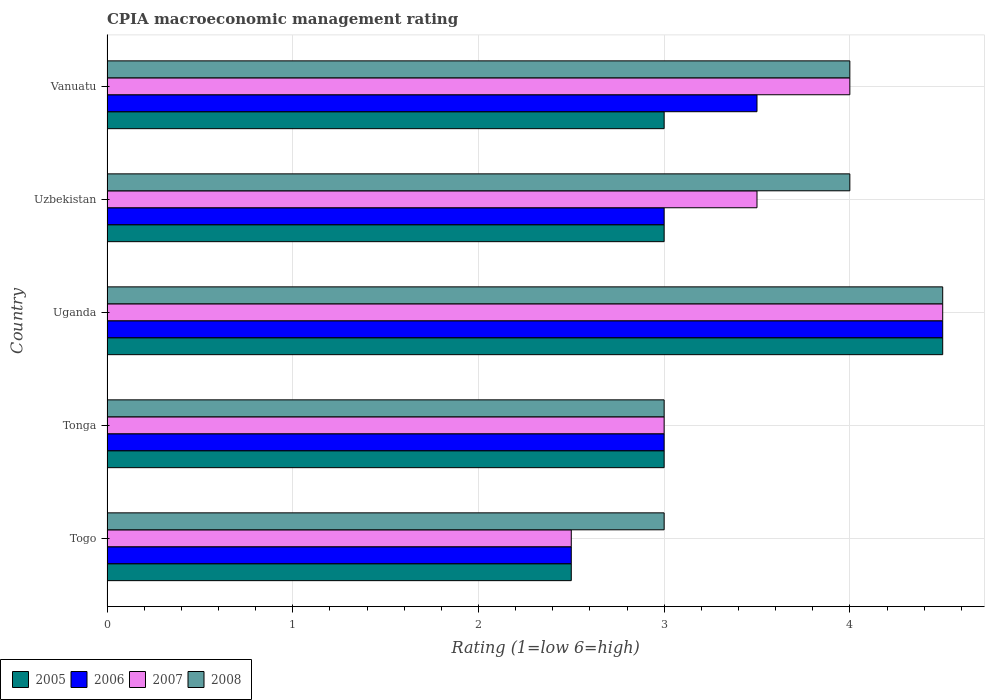How many bars are there on the 1st tick from the top?
Offer a very short reply. 4. What is the label of the 3rd group of bars from the top?
Your answer should be very brief. Uganda. In how many cases, is the number of bars for a given country not equal to the number of legend labels?
Provide a succinct answer. 0. Across all countries, what is the maximum CPIA rating in 2007?
Give a very brief answer. 4.5. In which country was the CPIA rating in 2008 maximum?
Make the answer very short. Uganda. In which country was the CPIA rating in 2006 minimum?
Your answer should be very brief. Togo. What is the difference between the CPIA rating in 2007 in Tonga and the CPIA rating in 2005 in Uganda?
Keep it short and to the point. -1.5. What is the ratio of the CPIA rating in 2005 in Tonga to that in Uganda?
Your answer should be very brief. 0.67. Is the difference between the CPIA rating in 2007 in Tonga and Uzbekistan greater than the difference between the CPIA rating in 2008 in Tonga and Uzbekistan?
Give a very brief answer. Yes. What is the difference between the highest and the second highest CPIA rating in 2007?
Give a very brief answer. 0.5. What is the difference between the highest and the lowest CPIA rating in 2005?
Provide a succinct answer. 2. In how many countries, is the CPIA rating in 2007 greater than the average CPIA rating in 2007 taken over all countries?
Your answer should be compact. 2. Is the sum of the CPIA rating in 2005 in Uganda and Uzbekistan greater than the maximum CPIA rating in 2006 across all countries?
Your response must be concise. Yes. Is it the case that in every country, the sum of the CPIA rating in 2007 and CPIA rating in 2006 is greater than the sum of CPIA rating in 2005 and CPIA rating in 2008?
Make the answer very short. No. How many countries are there in the graph?
Make the answer very short. 5. What is the difference between two consecutive major ticks on the X-axis?
Give a very brief answer. 1. Are the values on the major ticks of X-axis written in scientific E-notation?
Keep it short and to the point. No. Does the graph contain grids?
Provide a short and direct response. Yes. How are the legend labels stacked?
Offer a terse response. Horizontal. What is the title of the graph?
Provide a succinct answer. CPIA macroeconomic management rating. Does "2002" appear as one of the legend labels in the graph?
Your response must be concise. No. What is the label or title of the X-axis?
Offer a terse response. Rating (1=low 6=high). What is the Rating (1=low 6=high) in 2007 in Togo?
Offer a terse response. 2.5. What is the Rating (1=low 6=high) in 2005 in Tonga?
Your answer should be very brief. 3. What is the Rating (1=low 6=high) in 2007 in Tonga?
Your answer should be very brief. 3. What is the Rating (1=low 6=high) in 2008 in Tonga?
Offer a very short reply. 3. What is the Rating (1=low 6=high) of 2006 in Uganda?
Provide a short and direct response. 4.5. What is the Rating (1=low 6=high) in 2007 in Uzbekistan?
Provide a short and direct response. 3.5. What is the Rating (1=low 6=high) in 2007 in Vanuatu?
Ensure brevity in your answer.  4. What is the Rating (1=low 6=high) in 2008 in Vanuatu?
Provide a short and direct response. 4. Across all countries, what is the maximum Rating (1=low 6=high) in 2006?
Your answer should be compact. 4.5. Across all countries, what is the maximum Rating (1=low 6=high) of 2007?
Ensure brevity in your answer.  4.5. Across all countries, what is the minimum Rating (1=low 6=high) in 2005?
Ensure brevity in your answer.  2.5. Across all countries, what is the minimum Rating (1=low 6=high) in 2007?
Provide a succinct answer. 2.5. Across all countries, what is the minimum Rating (1=low 6=high) in 2008?
Offer a very short reply. 3. What is the total Rating (1=low 6=high) in 2006 in the graph?
Ensure brevity in your answer.  16.5. What is the total Rating (1=low 6=high) of 2007 in the graph?
Provide a succinct answer. 17.5. What is the difference between the Rating (1=low 6=high) of 2008 in Togo and that in Uzbekistan?
Provide a short and direct response. -1. What is the difference between the Rating (1=low 6=high) of 2006 in Togo and that in Vanuatu?
Provide a succinct answer. -1. What is the difference between the Rating (1=low 6=high) of 2008 in Togo and that in Vanuatu?
Your response must be concise. -1. What is the difference between the Rating (1=low 6=high) in 2006 in Tonga and that in Uganda?
Keep it short and to the point. -1.5. What is the difference between the Rating (1=low 6=high) of 2008 in Tonga and that in Uganda?
Provide a succinct answer. -1.5. What is the difference between the Rating (1=low 6=high) in 2006 in Tonga and that in Uzbekistan?
Your response must be concise. 0. What is the difference between the Rating (1=low 6=high) in 2007 in Tonga and that in Uzbekistan?
Offer a very short reply. -0.5. What is the difference between the Rating (1=low 6=high) of 2008 in Tonga and that in Uzbekistan?
Give a very brief answer. -1. What is the difference between the Rating (1=low 6=high) of 2005 in Tonga and that in Vanuatu?
Provide a short and direct response. 0. What is the difference between the Rating (1=low 6=high) of 2006 in Tonga and that in Vanuatu?
Ensure brevity in your answer.  -0.5. What is the difference between the Rating (1=low 6=high) in 2007 in Tonga and that in Vanuatu?
Your answer should be very brief. -1. What is the difference between the Rating (1=low 6=high) of 2008 in Uganda and that in Uzbekistan?
Your response must be concise. 0.5. What is the difference between the Rating (1=low 6=high) in 2007 in Uganda and that in Vanuatu?
Keep it short and to the point. 0.5. What is the difference between the Rating (1=low 6=high) of 2005 in Uzbekistan and that in Vanuatu?
Keep it short and to the point. 0. What is the difference between the Rating (1=low 6=high) of 2006 in Uzbekistan and that in Vanuatu?
Offer a terse response. -0.5. What is the difference between the Rating (1=low 6=high) in 2007 in Togo and the Rating (1=low 6=high) in 2008 in Tonga?
Keep it short and to the point. -0.5. What is the difference between the Rating (1=low 6=high) in 2005 in Togo and the Rating (1=low 6=high) in 2006 in Uganda?
Give a very brief answer. -2. What is the difference between the Rating (1=low 6=high) in 2006 in Togo and the Rating (1=low 6=high) in 2007 in Uganda?
Keep it short and to the point. -2. What is the difference between the Rating (1=low 6=high) of 2006 in Togo and the Rating (1=low 6=high) of 2008 in Uganda?
Offer a very short reply. -2. What is the difference between the Rating (1=low 6=high) in 2007 in Togo and the Rating (1=low 6=high) in 2008 in Uganda?
Your answer should be very brief. -2. What is the difference between the Rating (1=low 6=high) in 2005 in Togo and the Rating (1=low 6=high) in 2008 in Uzbekistan?
Ensure brevity in your answer.  -1.5. What is the difference between the Rating (1=low 6=high) in 2006 in Togo and the Rating (1=low 6=high) in 2007 in Uzbekistan?
Keep it short and to the point. -1. What is the difference between the Rating (1=low 6=high) of 2006 in Togo and the Rating (1=low 6=high) of 2007 in Vanuatu?
Give a very brief answer. -1.5. What is the difference between the Rating (1=low 6=high) of 2006 in Togo and the Rating (1=low 6=high) of 2008 in Vanuatu?
Give a very brief answer. -1.5. What is the difference between the Rating (1=low 6=high) in 2005 in Tonga and the Rating (1=low 6=high) in 2006 in Uganda?
Offer a terse response. -1.5. What is the difference between the Rating (1=low 6=high) of 2005 in Tonga and the Rating (1=low 6=high) of 2008 in Uganda?
Give a very brief answer. -1.5. What is the difference between the Rating (1=low 6=high) in 2005 in Tonga and the Rating (1=low 6=high) in 2006 in Uzbekistan?
Provide a short and direct response. 0. What is the difference between the Rating (1=low 6=high) in 2005 in Tonga and the Rating (1=low 6=high) in 2006 in Vanuatu?
Ensure brevity in your answer.  -0.5. What is the difference between the Rating (1=low 6=high) in 2005 in Tonga and the Rating (1=low 6=high) in 2008 in Vanuatu?
Offer a terse response. -1. What is the difference between the Rating (1=low 6=high) in 2006 in Tonga and the Rating (1=low 6=high) in 2008 in Vanuatu?
Give a very brief answer. -1. What is the difference between the Rating (1=low 6=high) in 2007 in Tonga and the Rating (1=low 6=high) in 2008 in Vanuatu?
Offer a terse response. -1. What is the difference between the Rating (1=low 6=high) of 2005 in Uganda and the Rating (1=low 6=high) of 2006 in Uzbekistan?
Keep it short and to the point. 1.5. What is the difference between the Rating (1=low 6=high) in 2005 in Uganda and the Rating (1=low 6=high) in 2008 in Uzbekistan?
Provide a short and direct response. 0.5. What is the difference between the Rating (1=low 6=high) in 2006 in Uganda and the Rating (1=low 6=high) in 2007 in Uzbekistan?
Ensure brevity in your answer.  1. What is the difference between the Rating (1=low 6=high) in 2006 in Uganda and the Rating (1=low 6=high) in 2008 in Uzbekistan?
Make the answer very short. 0.5. What is the difference between the Rating (1=low 6=high) of 2007 in Uganda and the Rating (1=low 6=high) of 2008 in Uzbekistan?
Provide a short and direct response. 0.5. What is the difference between the Rating (1=low 6=high) of 2005 in Uganda and the Rating (1=low 6=high) of 2006 in Vanuatu?
Provide a short and direct response. 1. What is the difference between the Rating (1=low 6=high) in 2005 in Uganda and the Rating (1=low 6=high) in 2007 in Vanuatu?
Your response must be concise. 0.5. What is the difference between the Rating (1=low 6=high) in 2005 in Uganda and the Rating (1=low 6=high) in 2008 in Vanuatu?
Offer a very short reply. 0.5. What is the difference between the Rating (1=low 6=high) in 2006 in Uganda and the Rating (1=low 6=high) in 2007 in Vanuatu?
Ensure brevity in your answer.  0.5. What is the difference between the Rating (1=low 6=high) in 2006 in Uganda and the Rating (1=low 6=high) in 2008 in Vanuatu?
Your answer should be compact. 0.5. What is the difference between the Rating (1=low 6=high) in 2007 in Uganda and the Rating (1=low 6=high) in 2008 in Vanuatu?
Your response must be concise. 0.5. What is the difference between the Rating (1=low 6=high) in 2005 in Uzbekistan and the Rating (1=low 6=high) in 2006 in Vanuatu?
Give a very brief answer. -0.5. What is the difference between the Rating (1=low 6=high) of 2005 in Uzbekistan and the Rating (1=low 6=high) of 2007 in Vanuatu?
Ensure brevity in your answer.  -1. What is the difference between the Rating (1=low 6=high) in 2005 in Uzbekistan and the Rating (1=low 6=high) in 2008 in Vanuatu?
Your answer should be very brief. -1. What is the difference between the Rating (1=low 6=high) of 2006 in Uzbekistan and the Rating (1=low 6=high) of 2007 in Vanuatu?
Provide a short and direct response. -1. What is the difference between the Rating (1=low 6=high) in 2006 in Uzbekistan and the Rating (1=low 6=high) in 2008 in Vanuatu?
Provide a succinct answer. -1. What is the difference between the Rating (1=low 6=high) in 2007 in Uzbekistan and the Rating (1=low 6=high) in 2008 in Vanuatu?
Provide a succinct answer. -0.5. What is the average Rating (1=low 6=high) of 2005 per country?
Keep it short and to the point. 3.2. What is the average Rating (1=low 6=high) in 2008 per country?
Your answer should be very brief. 3.7. What is the difference between the Rating (1=low 6=high) in 2005 and Rating (1=low 6=high) in 2007 in Togo?
Make the answer very short. 0. What is the difference between the Rating (1=low 6=high) of 2006 and Rating (1=low 6=high) of 2007 in Togo?
Give a very brief answer. 0. What is the difference between the Rating (1=low 6=high) in 2006 and Rating (1=low 6=high) in 2008 in Togo?
Keep it short and to the point. -0.5. What is the difference between the Rating (1=low 6=high) in 2005 and Rating (1=low 6=high) in 2006 in Tonga?
Make the answer very short. 0. What is the difference between the Rating (1=low 6=high) in 2006 and Rating (1=low 6=high) in 2007 in Tonga?
Offer a very short reply. 0. What is the difference between the Rating (1=low 6=high) of 2006 and Rating (1=low 6=high) of 2008 in Tonga?
Provide a succinct answer. 0. What is the difference between the Rating (1=low 6=high) of 2007 and Rating (1=low 6=high) of 2008 in Tonga?
Give a very brief answer. 0. What is the difference between the Rating (1=low 6=high) in 2005 and Rating (1=low 6=high) in 2007 in Uganda?
Give a very brief answer. 0. What is the difference between the Rating (1=low 6=high) of 2006 and Rating (1=low 6=high) of 2007 in Uganda?
Give a very brief answer. 0. What is the difference between the Rating (1=low 6=high) in 2006 and Rating (1=low 6=high) in 2008 in Uganda?
Your answer should be very brief. 0. What is the difference between the Rating (1=low 6=high) of 2005 and Rating (1=low 6=high) of 2006 in Uzbekistan?
Your response must be concise. 0. What is the difference between the Rating (1=low 6=high) in 2005 and Rating (1=low 6=high) in 2007 in Uzbekistan?
Give a very brief answer. -0.5. What is the difference between the Rating (1=low 6=high) in 2005 and Rating (1=low 6=high) in 2008 in Uzbekistan?
Offer a terse response. -1. What is the difference between the Rating (1=low 6=high) of 2006 and Rating (1=low 6=high) of 2008 in Uzbekistan?
Provide a succinct answer. -1. What is the difference between the Rating (1=low 6=high) of 2007 and Rating (1=low 6=high) of 2008 in Uzbekistan?
Your answer should be very brief. -0.5. What is the difference between the Rating (1=low 6=high) of 2006 and Rating (1=low 6=high) of 2007 in Vanuatu?
Provide a short and direct response. -0.5. What is the difference between the Rating (1=low 6=high) of 2006 and Rating (1=low 6=high) of 2008 in Vanuatu?
Offer a terse response. -0.5. What is the difference between the Rating (1=low 6=high) of 2007 and Rating (1=low 6=high) of 2008 in Vanuatu?
Your answer should be compact. 0. What is the ratio of the Rating (1=low 6=high) in 2005 in Togo to that in Tonga?
Your answer should be compact. 0.83. What is the ratio of the Rating (1=low 6=high) in 2006 in Togo to that in Tonga?
Your answer should be compact. 0.83. What is the ratio of the Rating (1=low 6=high) in 2007 in Togo to that in Tonga?
Your answer should be compact. 0.83. What is the ratio of the Rating (1=low 6=high) of 2005 in Togo to that in Uganda?
Your response must be concise. 0.56. What is the ratio of the Rating (1=low 6=high) of 2006 in Togo to that in Uganda?
Provide a short and direct response. 0.56. What is the ratio of the Rating (1=low 6=high) of 2007 in Togo to that in Uganda?
Give a very brief answer. 0.56. What is the ratio of the Rating (1=low 6=high) of 2008 in Togo to that in Uganda?
Make the answer very short. 0.67. What is the ratio of the Rating (1=low 6=high) of 2005 in Togo to that in Uzbekistan?
Provide a succinct answer. 0.83. What is the ratio of the Rating (1=low 6=high) of 2006 in Togo to that in Uzbekistan?
Provide a short and direct response. 0.83. What is the ratio of the Rating (1=low 6=high) in 2008 in Togo to that in Uzbekistan?
Make the answer very short. 0.75. What is the ratio of the Rating (1=low 6=high) of 2006 in Togo to that in Vanuatu?
Offer a terse response. 0.71. What is the ratio of the Rating (1=low 6=high) of 2005 in Tonga to that in Uganda?
Ensure brevity in your answer.  0.67. What is the ratio of the Rating (1=low 6=high) of 2007 in Tonga to that in Uganda?
Provide a succinct answer. 0.67. What is the ratio of the Rating (1=low 6=high) of 2008 in Tonga to that in Uganda?
Provide a succinct answer. 0.67. What is the ratio of the Rating (1=low 6=high) in 2006 in Tonga to that in Uzbekistan?
Provide a short and direct response. 1. What is the ratio of the Rating (1=low 6=high) in 2007 in Tonga to that in Uzbekistan?
Provide a succinct answer. 0.86. What is the ratio of the Rating (1=low 6=high) of 2008 in Tonga to that in Uzbekistan?
Your response must be concise. 0.75. What is the ratio of the Rating (1=low 6=high) of 2005 in Tonga to that in Vanuatu?
Offer a terse response. 1. What is the ratio of the Rating (1=low 6=high) in 2006 in Tonga to that in Vanuatu?
Provide a succinct answer. 0.86. What is the ratio of the Rating (1=low 6=high) in 2008 in Tonga to that in Vanuatu?
Provide a succinct answer. 0.75. What is the ratio of the Rating (1=low 6=high) in 2008 in Uganda to that in Uzbekistan?
Provide a succinct answer. 1.12. What is the ratio of the Rating (1=low 6=high) in 2005 in Uganda to that in Vanuatu?
Your answer should be very brief. 1.5. What is the ratio of the Rating (1=low 6=high) of 2005 in Uzbekistan to that in Vanuatu?
Your answer should be very brief. 1. What is the ratio of the Rating (1=low 6=high) of 2008 in Uzbekistan to that in Vanuatu?
Offer a terse response. 1. What is the difference between the highest and the second highest Rating (1=low 6=high) of 2005?
Your response must be concise. 1.5. What is the difference between the highest and the second highest Rating (1=low 6=high) in 2007?
Offer a very short reply. 0.5. What is the difference between the highest and the second highest Rating (1=low 6=high) of 2008?
Give a very brief answer. 0.5. What is the difference between the highest and the lowest Rating (1=low 6=high) in 2006?
Your answer should be compact. 2. What is the difference between the highest and the lowest Rating (1=low 6=high) in 2007?
Keep it short and to the point. 2. 